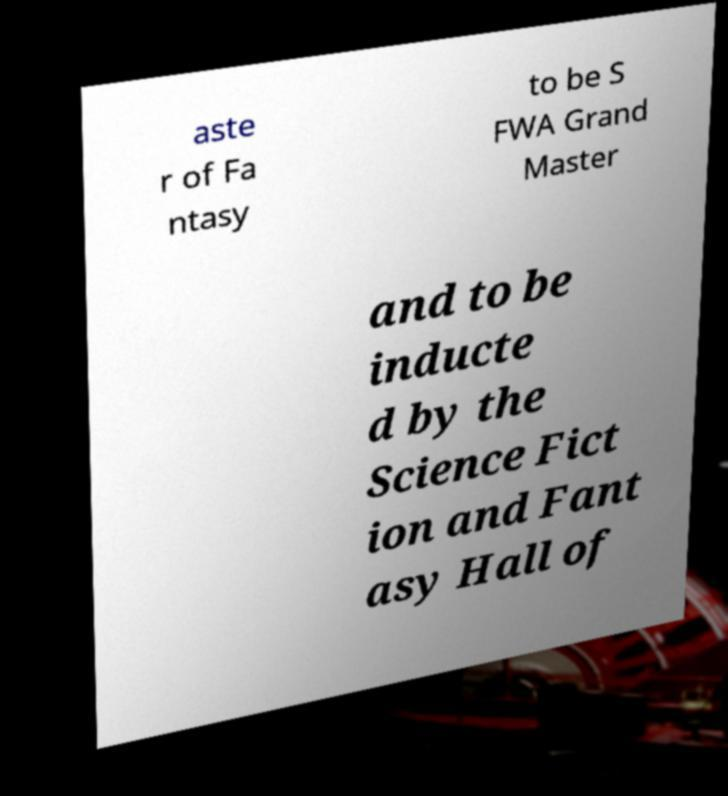Can you accurately transcribe the text from the provided image for me? aste r of Fa ntasy to be S FWA Grand Master and to be inducte d by the Science Fict ion and Fant asy Hall of 